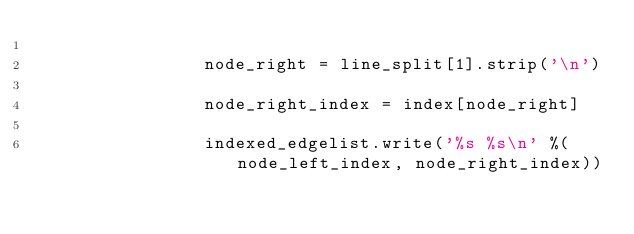Convert code to text. <code><loc_0><loc_0><loc_500><loc_500><_Python_>
				node_right = line_split[1].strip('\n')

				node_right_index = index[node_right]

				indexed_edgelist.write('%s %s\n' %(node_left_index, node_right_index))



</code> 